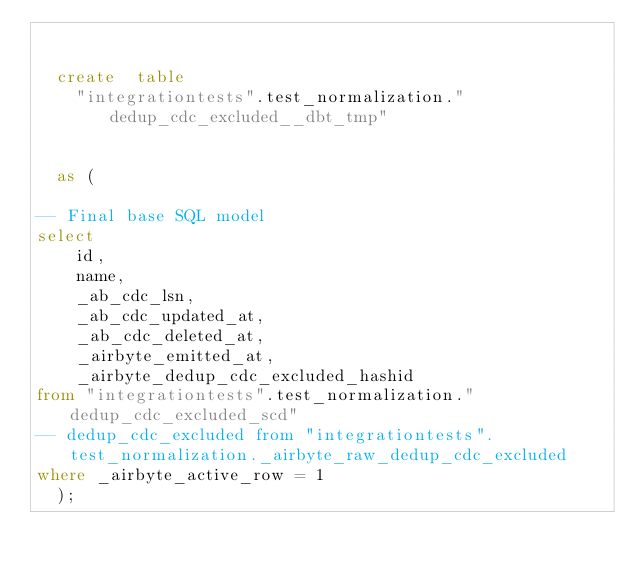Convert code to text. <code><loc_0><loc_0><loc_500><loc_500><_SQL_>

  create  table
    "integrationtests".test_normalization."dedup_cdc_excluded__dbt_tmp"
    
    
  as (
    
-- Final base SQL model
select
    id,
    name,
    _ab_cdc_lsn,
    _ab_cdc_updated_at,
    _ab_cdc_deleted_at,
    _airbyte_emitted_at,
    _airbyte_dedup_cdc_excluded_hashid
from "integrationtests".test_normalization."dedup_cdc_excluded_scd"
-- dedup_cdc_excluded from "integrationtests".test_normalization._airbyte_raw_dedup_cdc_excluded
where _airbyte_active_row = 1
  );</code> 